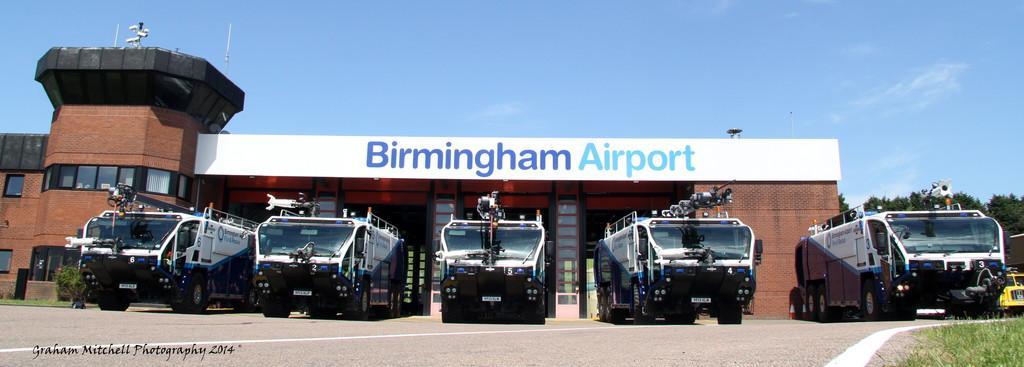In one or two sentences, can you explain what this image depicts? In this image I can see few vehicles on the road. Back I can see a building and window. Building is in brown color. I can see trees. The sky is in white and blue color. 